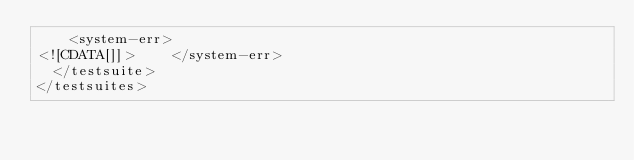Convert code to text. <code><loc_0><loc_0><loc_500><loc_500><_XML_>		<system-err>
<![CDATA[]]>		</system-err>
	</testsuite>
</testsuites>
</code> 